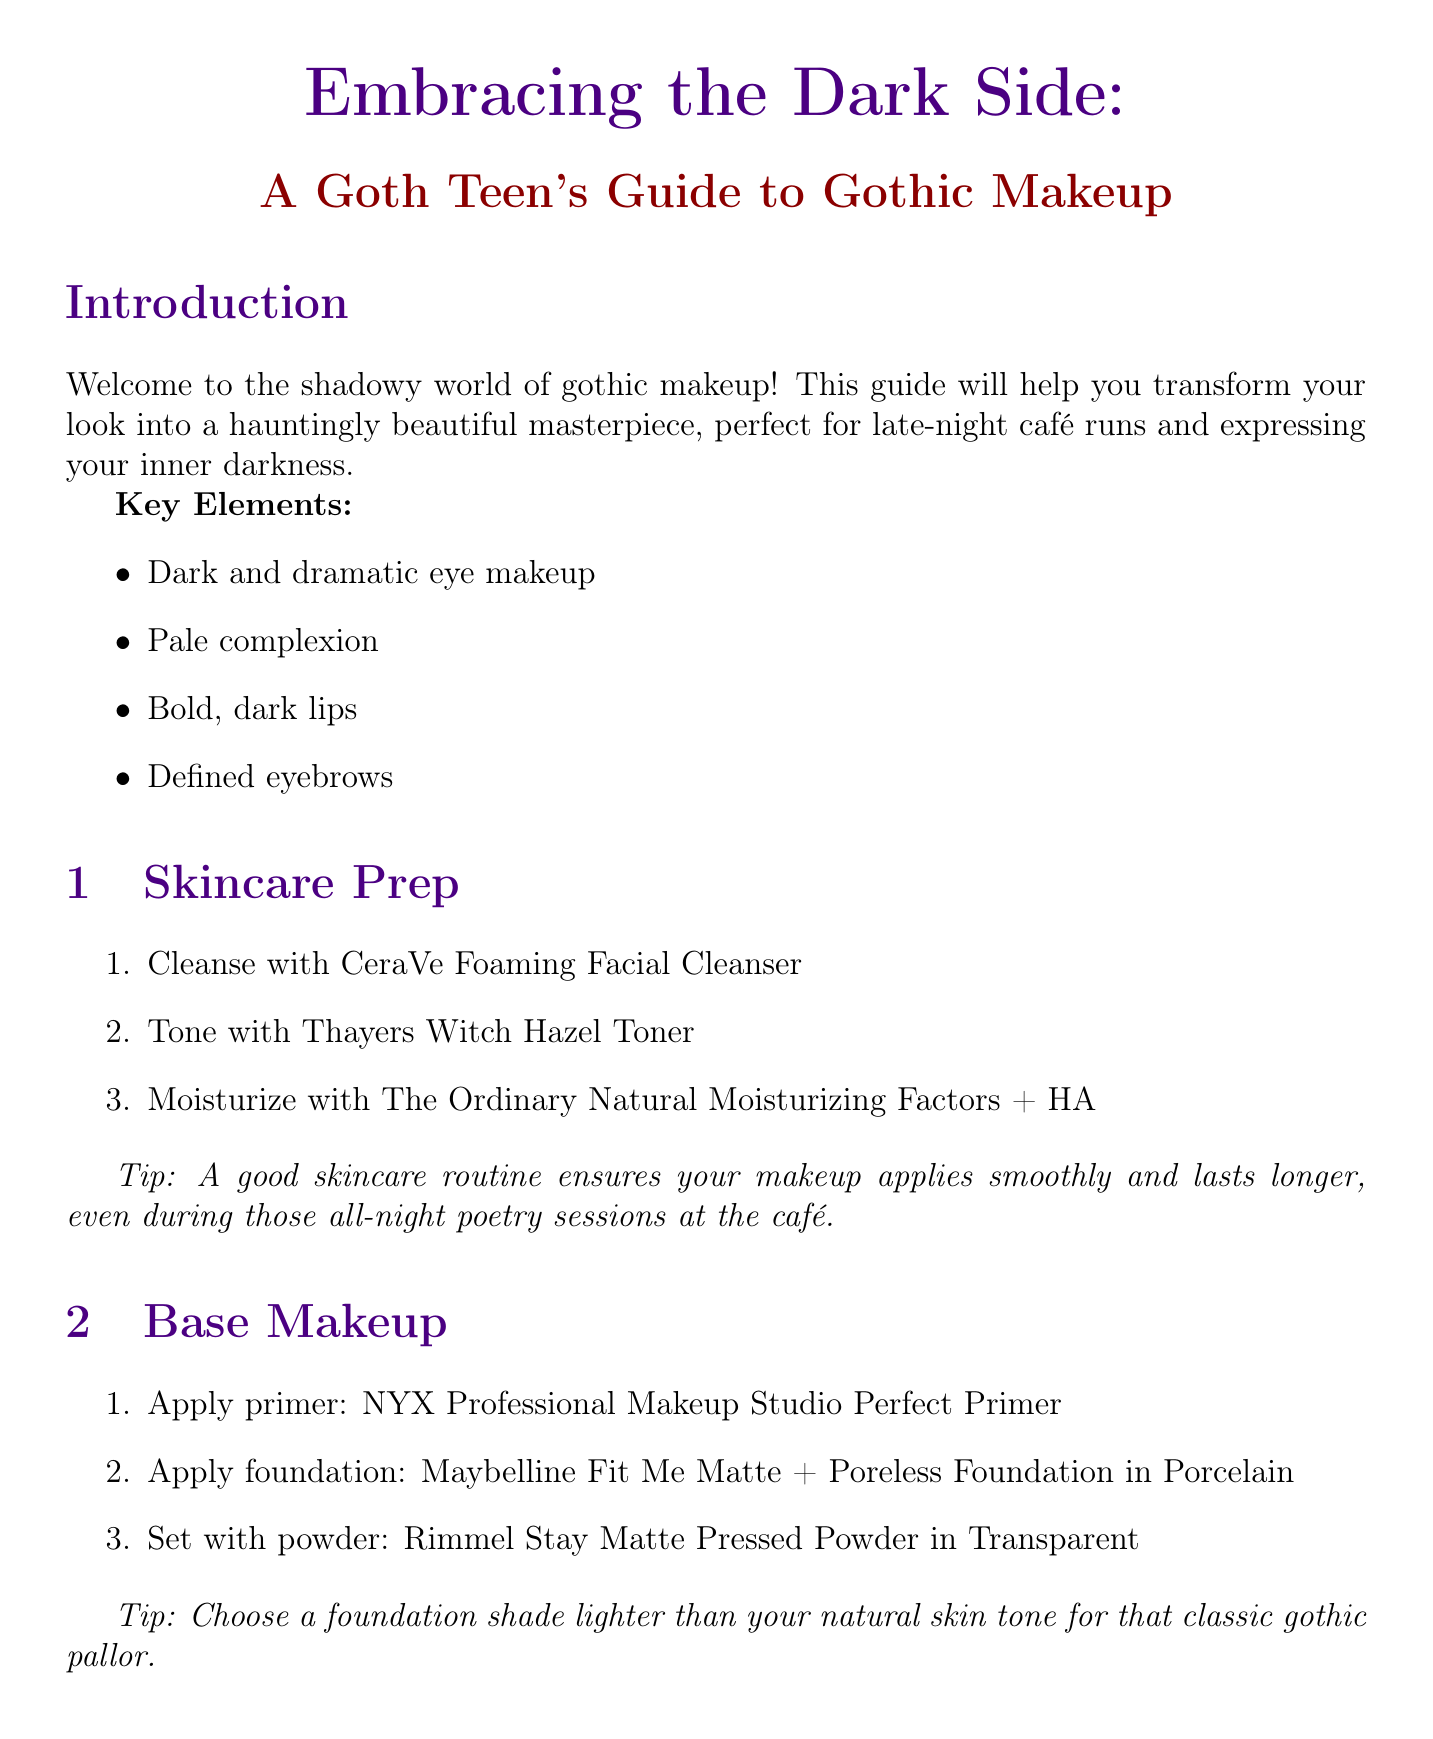What are the key elements of gothic makeup? The key elements are listed in the introduction and include dark eye makeup, pale complexion, bold lips, and defined eyebrows.
Answer: Dark and dramatic eye makeup, Pale complexion, Bold, dark lips, Defined eyebrows What product is recommended for moisturizing? The skincare prep section lists moisturizers, specifying "The Ordinary Natural Moisturizing Factors + HA" for moisturizing.
Answer: The Ordinary Natural Moisturizing Factors + HA What is the technique for applying foundation? The document states to use a damp beauty sponge for applying foundation to achieve a flawless finish.
Answer: Use a damp beauty sponge for a flawless finish What product should be used to prime eyelids? The eye makeup section specifies "Urban Decay Eyeshadow Primer Potion" as the product for priming eyelids.
Answer: Urban Decay Eyeshadow Primer Potion Which lipstick is recommended for a bold lip look? The lip section recommends "Kat Von D Everlasting Liquid Lipstick in Witches" for a bold lip look.
Answer: Kat Von D Everlasting Liquid Lipstick in Witches What is a suggested tip for brow filling? The document advises using light, feathery strokes to mimic natural hair when filling in brows.
Answer: Use light, feathery strokes to mimic natural hair How can you achieve a dramatic wing in eye makeup? The eye makeup section states that to line the eyes, one should create a dramatic wing with "Stila Stay All Day Waterproof Liquid Eye Liner in Intense Black."
Answer: Create a dramatic wing What product is recommended for setting makeup? The maintenance section mentions "Urban Decay All Nighter Long-Lasting Makeup Setting Spray" as a product to set makeup.
Answer: Urban Decay All Nighter Long-Lasting Makeup Setting Spray 